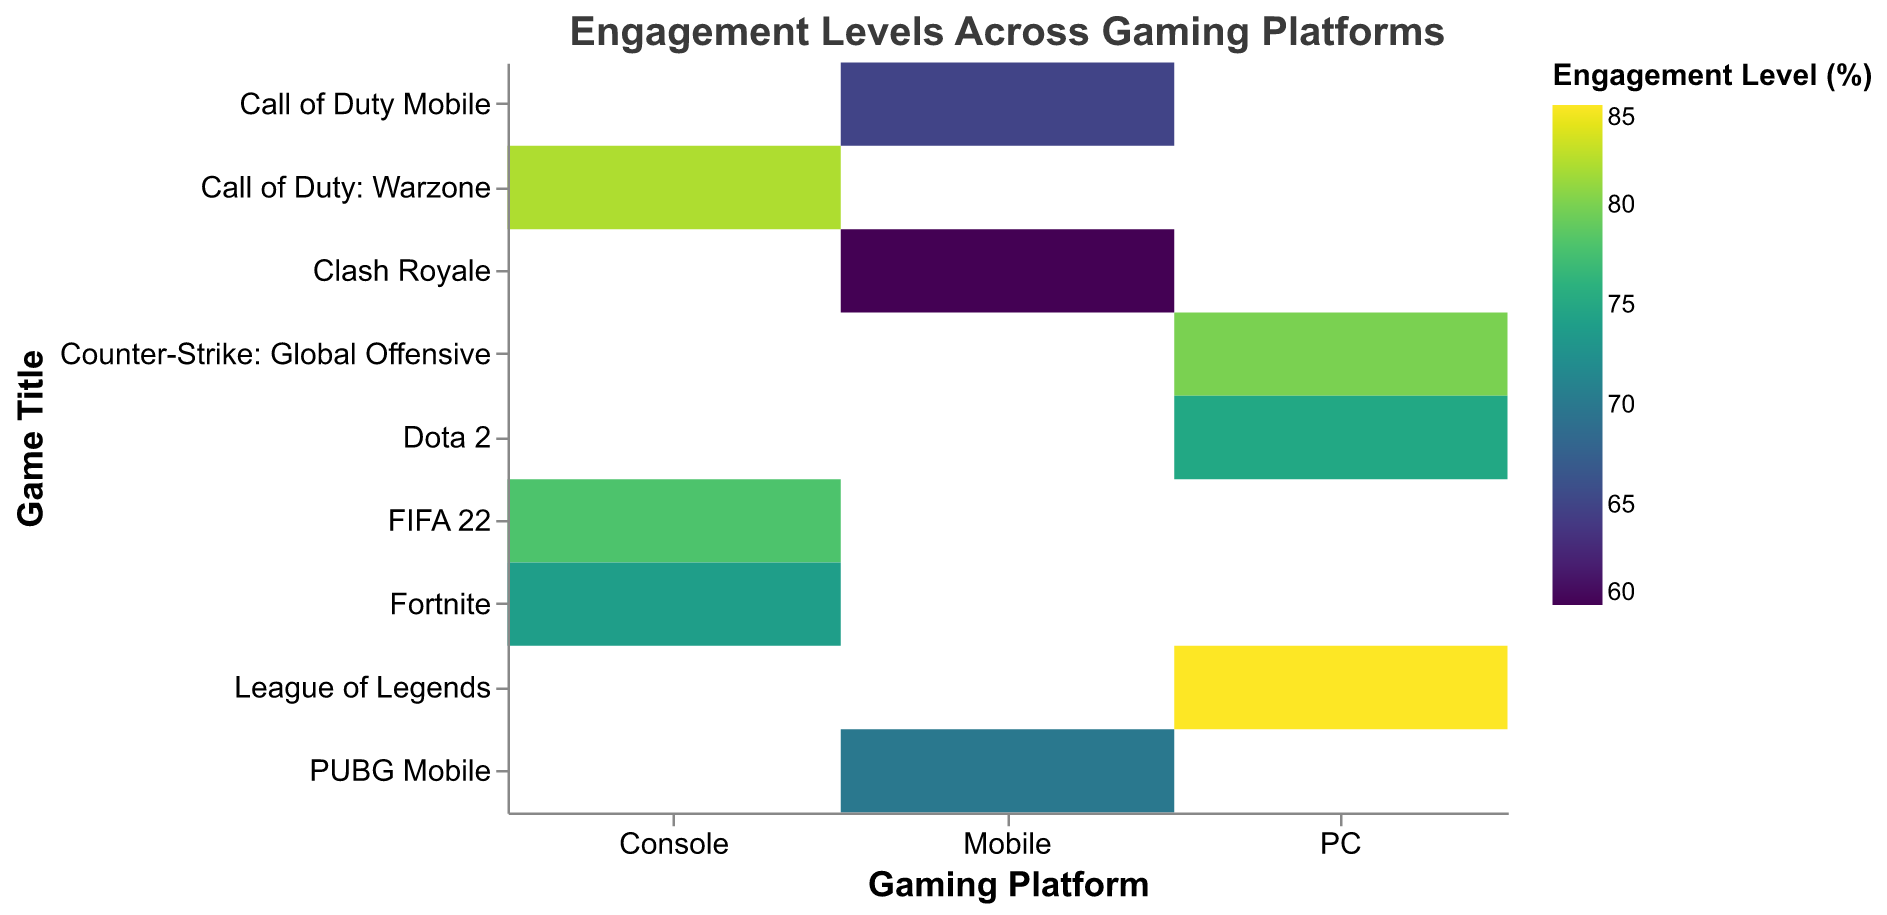What is the title of the heatmap? The title is displayed above the heatmap and reads "Engagement Levels Across Gaming Platforms".
Answer: Engagement Levels Across Gaming Platforms Which platform has the highest engagement level for any game, and what is the level? By looking at the heatmap, the brightest color (indicative of the highest engagement level) is seen for "League of Legends" on the PC platform with an engagement level of 85%.
Answer: PC, 85% How many games are represented on the console platform? The console platform has three rows in the heatmap, each corresponding to a different game title.
Answer: 3 Which game has the lowest engagement level on the mobile platform, and what is its level? By identifying the darkest color on the mobile platform section, "Clash Royale" has the lowest engagement level at 60%.
Answer: Clash Royale, 60% Compare the engagement levels of "Call of Duty: Warzone" and "Fortnite" on the console platform. Which game has a higher level? By comparing the colors and values associated with "Call of Duty: Warzone" and "Fortnite," "Call of Duty: Warzone" has a higher engagement level at 82% versus Fortnite's 74%.
Answer: Call of Duty: Warzone What is the average engagement level of all games on the PC platform? The engagement levels for PC games are 85%, 80%, and 75%. Average is calculated as (85 + 80 + 75) / 3 = 80%.
Answer: 80% Which platform overall shows the highest average engagement level? Calculate the averages for each platform: PC (80%), Console (78%), Mobile (65%). PC has the highest average engagement level.
Answer: PC Are there any games with the same engagement level across different platforms? No, all games have unique engagement levels when displayed in the heatmap.
Answer: No Which platform has the largest range of engagement levels among its games? Calculate the range (max - min) for each platform: PC (85-75=10), Console (82-74=8), Mobile (70-60=10). Both PC and Mobile have the largest range of 10%.
Answer: PC and Mobile 